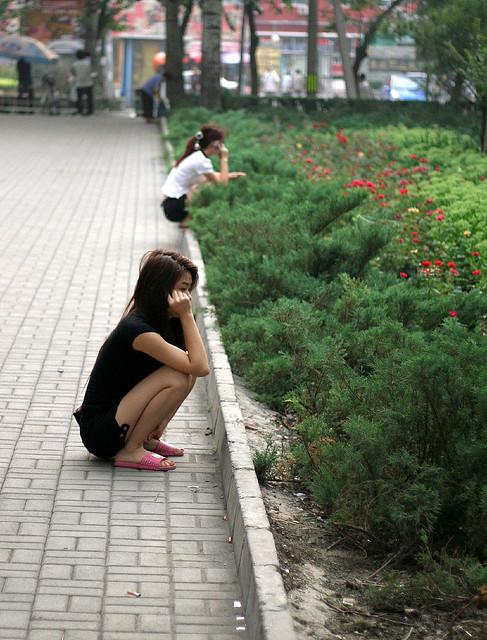What color shoes do you see?
Answer briefly. Pink. Can you see the red butterfly?
Write a very short answer. No. Why are the women crouching down?
Answer briefly. Looking at plants. 